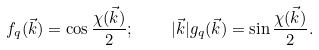Convert formula to latex. <formula><loc_0><loc_0><loc_500><loc_500>f _ { q } ( \vec { k } ) = \cos \frac { \chi ( \vec { k } ) } { 2 } ; \quad | \vec { k } | g _ { q } ( \vec { k } ) = \sin \frac { \chi ( \vec { k } ) } { 2 } .</formula> 